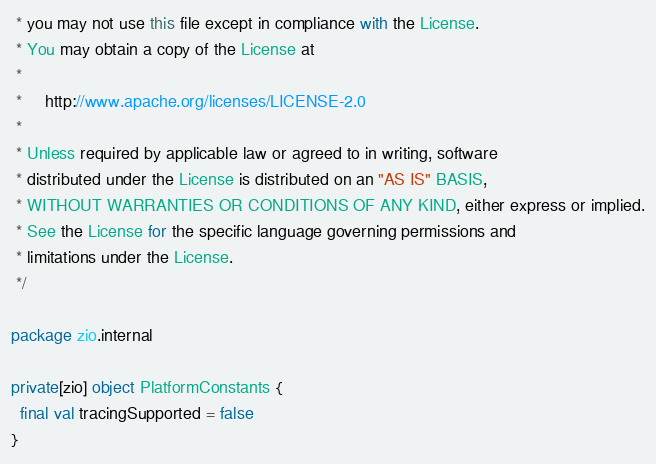Convert code to text. <code><loc_0><loc_0><loc_500><loc_500><_Scala_> * you may not use this file except in compliance with the License.
 * You may obtain a copy of the License at
 *
 *     http://www.apache.org/licenses/LICENSE-2.0
 *
 * Unless required by applicable law or agreed to in writing, software
 * distributed under the License is distributed on an "AS IS" BASIS,
 * WITHOUT WARRANTIES OR CONDITIONS OF ANY KIND, either express or implied.
 * See the License for the specific language governing permissions and
 * limitations under the License.
 */

package zio.internal

private[zio] object PlatformConstants {
  final val tracingSupported = false
}
</code> 